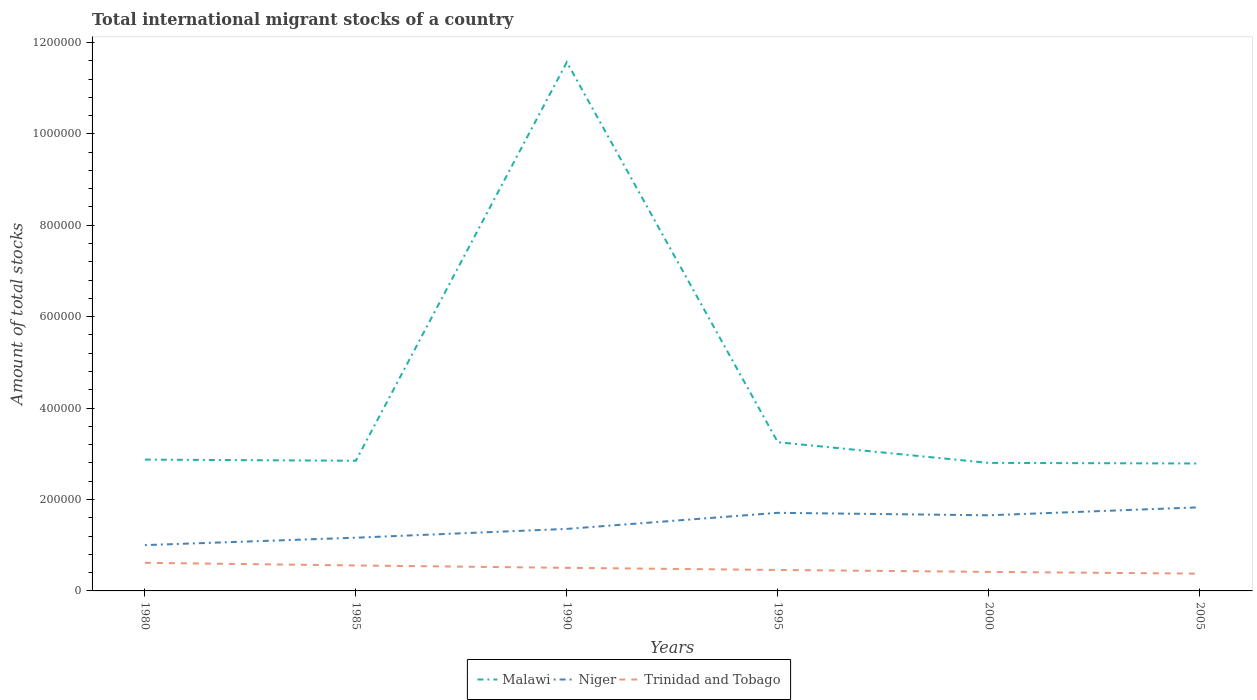Is the number of lines equal to the number of legend labels?
Offer a terse response. Yes. Across all years, what is the maximum amount of total stocks in in Trinidad and Tobago?
Provide a succinct answer. 3.78e+04. In which year was the amount of total stocks in in Niger maximum?
Your response must be concise. 1980. What is the total amount of total stocks in in Niger in the graph?
Offer a terse response. -3.52e+04. What is the difference between the highest and the second highest amount of total stocks in in Niger?
Offer a very short reply. 8.27e+04. How many lines are there?
Ensure brevity in your answer.  3. Does the graph contain any zero values?
Your answer should be very brief. No. Where does the legend appear in the graph?
Your answer should be very brief. Bottom center. How many legend labels are there?
Offer a very short reply. 3. How are the legend labels stacked?
Ensure brevity in your answer.  Horizontal. What is the title of the graph?
Ensure brevity in your answer.  Total international migrant stocks of a country. What is the label or title of the X-axis?
Your response must be concise. Years. What is the label or title of the Y-axis?
Offer a very short reply. Amount of total stocks. What is the Amount of total stocks in Malawi in 1980?
Ensure brevity in your answer.  2.87e+05. What is the Amount of total stocks in Niger in 1980?
Make the answer very short. 1.00e+05. What is the Amount of total stocks in Trinidad and Tobago in 1980?
Make the answer very short. 6.15e+04. What is the Amount of total stocks of Malawi in 1985?
Your response must be concise. 2.85e+05. What is the Amount of total stocks in Niger in 1985?
Offer a terse response. 1.16e+05. What is the Amount of total stocks in Trinidad and Tobago in 1985?
Provide a succinct answer. 5.57e+04. What is the Amount of total stocks of Malawi in 1990?
Offer a terse response. 1.16e+06. What is the Amount of total stocks of Niger in 1990?
Provide a short and direct response. 1.36e+05. What is the Amount of total stocks of Trinidad and Tobago in 1990?
Give a very brief answer. 5.05e+04. What is the Amount of total stocks of Malawi in 1995?
Make the answer very short. 3.25e+05. What is the Amount of total stocks of Niger in 1995?
Ensure brevity in your answer.  1.71e+05. What is the Amount of total stocks in Trinidad and Tobago in 1995?
Your answer should be compact. 4.59e+04. What is the Amount of total stocks of Malawi in 2000?
Your answer should be very brief. 2.80e+05. What is the Amount of total stocks in Niger in 2000?
Offer a terse response. 1.65e+05. What is the Amount of total stocks of Trinidad and Tobago in 2000?
Offer a very short reply. 4.16e+04. What is the Amount of total stocks in Malawi in 2005?
Your answer should be compact. 2.79e+05. What is the Amount of total stocks of Niger in 2005?
Your response must be concise. 1.83e+05. What is the Amount of total stocks of Trinidad and Tobago in 2005?
Give a very brief answer. 3.78e+04. Across all years, what is the maximum Amount of total stocks in Malawi?
Keep it short and to the point. 1.16e+06. Across all years, what is the maximum Amount of total stocks of Niger?
Provide a succinct answer. 1.83e+05. Across all years, what is the maximum Amount of total stocks of Trinidad and Tobago?
Provide a short and direct response. 6.15e+04. Across all years, what is the minimum Amount of total stocks in Malawi?
Your answer should be compact. 2.79e+05. Across all years, what is the minimum Amount of total stocks of Niger?
Your answer should be compact. 1.00e+05. Across all years, what is the minimum Amount of total stocks of Trinidad and Tobago?
Keep it short and to the point. 3.78e+04. What is the total Amount of total stocks of Malawi in the graph?
Offer a very short reply. 2.61e+06. What is the total Amount of total stocks of Niger in the graph?
Provide a short and direct response. 8.72e+05. What is the total Amount of total stocks in Trinidad and Tobago in the graph?
Your answer should be very brief. 2.93e+05. What is the difference between the Amount of total stocks in Malawi in 1980 and that in 1985?
Make the answer very short. 2540. What is the difference between the Amount of total stocks in Niger in 1980 and that in 1985?
Give a very brief answer. -1.62e+04. What is the difference between the Amount of total stocks in Trinidad and Tobago in 1980 and that in 1985?
Give a very brief answer. 5778. What is the difference between the Amount of total stocks in Malawi in 1980 and that in 1990?
Offer a very short reply. -8.70e+05. What is the difference between the Amount of total stocks in Niger in 1980 and that in 1990?
Offer a very short reply. -3.55e+04. What is the difference between the Amount of total stocks of Trinidad and Tobago in 1980 and that in 1990?
Your answer should be compact. 1.10e+04. What is the difference between the Amount of total stocks in Malawi in 1980 and that in 1995?
Keep it short and to the point. -3.81e+04. What is the difference between the Amount of total stocks of Niger in 1980 and that in 1995?
Your answer should be very brief. -7.06e+04. What is the difference between the Amount of total stocks of Trinidad and Tobago in 1980 and that in 1995?
Your answer should be compact. 1.56e+04. What is the difference between the Amount of total stocks in Malawi in 1980 and that in 2000?
Offer a terse response. 7226. What is the difference between the Amount of total stocks of Niger in 1980 and that in 2000?
Your answer should be compact. -6.52e+04. What is the difference between the Amount of total stocks in Trinidad and Tobago in 1980 and that in 2000?
Your answer should be compact. 1.99e+04. What is the difference between the Amount of total stocks in Malawi in 1980 and that in 2005?
Keep it short and to the point. 8516. What is the difference between the Amount of total stocks in Niger in 1980 and that in 2005?
Provide a short and direct response. -8.27e+04. What is the difference between the Amount of total stocks in Trinidad and Tobago in 1980 and that in 2005?
Keep it short and to the point. 2.37e+04. What is the difference between the Amount of total stocks of Malawi in 1985 and that in 1990?
Offer a terse response. -8.72e+05. What is the difference between the Amount of total stocks in Niger in 1985 and that in 1990?
Make the answer very short. -1.92e+04. What is the difference between the Amount of total stocks of Trinidad and Tobago in 1985 and that in 1990?
Ensure brevity in your answer.  5232. What is the difference between the Amount of total stocks of Malawi in 1985 and that in 1995?
Give a very brief answer. -4.06e+04. What is the difference between the Amount of total stocks in Niger in 1985 and that in 1995?
Make the answer very short. -5.44e+04. What is the difference between the Amount of total stocks in Trinidad and Tobago in 1985 and that in 1995?
Your answer should be very brief. 9872. What is the difference between the Amount of total stocks of Malawi in 1985 and that in 2000?
Offer a very short reply. 4686. What is the difference between the Amount of total stocks in Niger in 1985 and that in 2000?
Offer a very short reply. -4.90e+04. What is the difference between the Amount of total stocks of Trinidad and Tobago in 1985 and that in 2000?
Your answer should be very brief. 1.41e+04. What is the difference between the Amount of total stocks in Malawi in 1985 and that in 2005?
Offer a terse response. 5976. What is the difference between the Amount of total stocks of Niger in 1985 and that in 2005?
Make the answer very short. -6.65e+04. What is the difference between the Amount of total stocks in Trinidad and Tobago in 1985 and that in 2005?
Your answer should be very brief. 1.79e+04. What is the difference between the Amount of total stocks in Malawi in 1990 and that in 1995?
Ensure brevity in your answer.  8.31e+05. What is the difference between the Amount of total stocks of Niger in 1990 and that in 1995?
Ensure brevity in your answer.  -3.52e+04. What is the difference between the Amount of total stocks of Trinidad and Tobago in 1990 and that in 1995?
Offer a very short reply. 4640. What is the difference between the Amount of total stocks of Malawi in 1990 and that in 2000?
Offer a very short reply. 8.77e+05. What is the difference between the Amount of total stocks in Niger in 1990 and that in 2000?
Your answer should be very brief. -2.98e+04. What is the difference between the Amount of total stocks of Trinidad and Tobago in 1990 and that in 2000?
Offer a terse response. 8854. What is the difference between the Amount of total stocks in Malawi in 1990 and that in 2005?
Ensure brevity in your answer.  8.78e+05. What is the difference between the Amount of total stocks in Niger in 1990 and that in 2005?
Offer a terse response. -4.73e+04. What is the difference between the Amount of total stocks in Trinidad and Tobago in 1990 and that in 2005?
Your answer should be very brief. 1.27e+04. What is the difference between the Amount of total stocks in Malawi in 1995 and that in 2000?
Offer a very short reply. 4.53e+04. What is the difference between the Amount of total stocks in Niger in 1995 and that in 2000?
Your response must be concise. 5416. What is the difference between the Amount of total stocks of Trinidad and Tobago in 1995 and that in 2000?
Your response must be concise. 4214. What is the difference between the Amount of total stocks of Malawi in 1995 and that in 2005?
Your answer should be compact. 4.66e+04. What is the difference between the Amount of total stocks of Niger in 1995 and that in 2005?
Give a very brief answer. -1.21e+04. What is the difference between the Amount of total stocks of Trinidad and Tobago in 1995 and that in 2005?
Ensure brevity in your answer.  8041. What is the difference between the Amount of total stocks in Malawi in 2000 and that in 2005?
Provide a short and direct response. 1290. What is the difference between the Amount of total stocks of Niger in 2000 and that in 2005?
Provide a short and direct response. -1.75e+04. What is the difference between the Amount of total stocks in Trinidad and Tobago in 2000 and that in 2005?
Your answer should be very brief. 3827. What is the difference between the Amount of total stocks in Malawi in 1980 and the Amount of total stocks in Niger in 1985?
Ensure brevity in your answer.  1.71e+05. What is the difference between the Amount of total stocks of Malawi in 1980 and the Amount of total stocks of Trinidad and Tobago in 1985?
Offer a very short reply. 2.32e+05. What is the difference between the Amount of total stocks of Niger in 1980 and the Amount of total stocks of Trinidad and Tobago in 1985?
Your response must be concise. 4.45e+04. What is the difference between the Amount of total stocks in Malawi in 1980 and the Amount of total stocks in Niger in 1990?
Your answer should be compact. 1.52e+05. What is the difference between the Amount of total stocks of Malawi in 1980 and the Amount of total stocks of Trinidad and Tobago in 1990?
Provide a succinct answer. 2.37e+05. What is the difference between the Amount of total stocks in Niger in 1980 and the Amount of total stocks in Trinidad and Tobago in 1990?
Ensure brevity in your answer.  4.97e+04. What is the difference between the Amount of total stocks in Malawi in 1980 and the Amount of total stocks in Niger in 1995?
Keep it short and to the point. 1.16e+05. What is the difference between the Amount of total stocks in Malawi in 1980 and the Amount of total stocks in Trinidad and Tobago in 1995?
Make the answer very short. 2.41e+05. What is the difference between the Amount of total stocks in Niger in 1980 and the Amount of total stocks in Trinidad and Tobago in 1995?
Your response must be concise. 5.44e+04. What is the difference between the Amount of total stocks in Malawi in 1980 and the Amount of total stocks in Niger in 2000?
Offer a very short reply. 1.22e+05. What is the difference between the Amount of total stocks in Malawi in 1980 and the Amount of total stocks in Trinidad and Tobago in 2000?
Your answer should be very brief. 2.46e+05. What is the difference between the Amount of total stocks of Niger in 1980 and the Amount of total stocks of Trinidad and Tobago in 2000?
Offer a terse response. 5.86e+04. What is the difference between the Amount of total stocks in Malawi in 1980 and the Amount of total stocks in Niger in 2005?
Your answer should be compact. 1.04e+05. What is the difference between the Amount of total stocks in Malawi in 1980 and the Amount of total stocks in Trinidad and Tobago in 2005?
Ensure brevity in your answer.  2.49e+05. What is the difference between the Amount of total stocks of Niger in 1980 and the Amount of total stocks of Trinidad and Tobago in 2005?
Your response must be concise. 6.24e+04. What is the difference between the Amount of total stocks of Malawi in 1985 and the Amount of total stocks of Niger in 1990?
Your response must be concise. 1.49e+05. What is the difference between the Amount of total stocks in Malawi in 1985 and the Amount of total stocks in Trinidad and Tobago in 1990?
Your answer should be compact. 2.34e+05. What is the difference between the Amount of total stocks of Niger in 1985 and the Amount of total stocks of Trinidad and Tobago in 1990?
Make the answer very short. 6.60e+04. What is the difference between the Amount of total stocks of Malawi in 1985 and the Amount of total stocks of Niger in 1995?
Make the answer very short. 1.14e+05. What is the difference between the Amount of total stocks in Malawi in 1985 and the Amount of total stocks in Trinidad and Tobago in 1995?
Keep it short and to the point. 2.39e+05. What is the difference between the Amount of total stocks of Niger in 1985 and the Amount of total stocks of Trinidad and Tobago in 1995?
Your answer should be compact. 7.06e+04. What is the difference between the Amount of total stocks of Malawi in 1985 and the Amount of total stocks of Niger in 2000?
Offer a terse response. 1.19e+05. What is the difference between the Amount of total stocks of Malawi in 1985 and the Amount of total stocks of Trinidad and Tobago in 2000?
Ensure brevity in your answer.  2.43e+05. What is the difference between the Amount of total stocks of Niger in 1985 and the Amount of total stocks of Trinidad and Tobago in 2000?
Ensure brevity in your answer.  7.48e+04. What is the difference between the Amount of total stocks in Malawi in 1985 and the Amount of total stocks in Niger in 2005?
Provide a short and direct response. 1.02e+05. What is the difference between the Amount of total stocks in Malawi in 1985 and the Amount of total stocks in Trinidad and Tobago in 2005?
Provide a short and direct response. 2.47e+05. What is the difference between the Amount of total stocks in Niger in 1985 and the Amount of total stocks in Trinidad and Tobago in 2005?
Provide a succinct answer. 7.86e+04. What is the difference between the Amount of total stocks of Malawi in 1990 and the Amount of total stocks of Niger in 1995?
Your answer should be compact. 9.86e+05. What is the difference between the Amount of total stocks in Malawi in 1990 and the Amount of total stocks in Trinidad and Tobago in 1995?
Offer a very short reply. 1.11e+06. What is the difference between the Amount of total stocks of Niger in 1990 and the Amount of total stocks of Trinidad and Tobago in 1995?
Provide a short and direct response. 8.98e+04. What is the difference between the Amount of total stocks in Malawi in 1990 and the Amount of total stocks in Niger in 2000?
Give a very brief answer. 9.91e+05. What is the difference between the Amount of total stocks of Malawi in 1990 and the Amount of total stocks of Trinidad and Tobago in 2000?
Your answer should be very brief. 1.12e+06. What is the difference between the Amount of total stocks in Niger in 1990 and the Amount of total stocks in Trinidad and Tobago in 2000?
Offer a very short reply. 9.40e+04. What is the difference between the Amount of total stocks of Malawi in 1990 and the Amount of total stocks of Niger in 2005?
Keep it short and to the point. 9.74e+05. What is the difference between the Amount of total stocks in Malawi in 1990 and the Amount of total stocks in Trinidad and Tobago in 2005?
Provide a short and direct response. 1.12e+06. What is the difference between the Amount of total stocks in Niger in 1990 and the Amount of total stocks in Trinidad and Tobago in 2005?
Keep it short and to the point. 9.79e+04. What is the difference between the Amount of total stocks in Malawi in 1995 and the Amount of total stocks in Niger in 2000?
Ensure brevity in your answer.  1.60e+05. What is the difference between the Amount of total stocks of Malawi in 1995 and the Amount of total stocks of Trinidad and Tobago in 2000?
Offer a terse response. 2.84e+05. What is the difference between the Amount of total stocks in Niger in 1995 and the Amount of total stocks in Trinidad and Tobago in 2000?
Your answer should be very brief. 1.29e+05. What is the difference between the Amount of total stocks in Malawi in 1995 and the Amount of total stocks in Niger in 2005?
Offer a very short reply. 1.42e+05. What is the difference between the Amount of total stocks in Malawi in 1995 and the Amount of total stocks in Trinidad and Tobago in 2005?
Your response must be concise. 2.88e+05. What is the difference between the Amount of total stocks in Niger in 1995 and the Amount of total stocks in Trinidad and Tobago in 2005?
Your answer should be compact. 1.33e+05. What is the difference between the Amount of total stocks in Malawi in 2000 and the Amount of total stocks in Niger in 2005?
Ensure brevity in your answer.  9.71e+04. What is the difference between the Amount of total stocks of Malawi in 2000 and the Amount of total stocks of Trinidad and Tobago in 2005?
Provide a short and direct response. 2.42e+05. What is the difference between the Amount of total stocks in Niger in 2000 and the Amount of total stocks in Trinidad and Tobago in 2005?
Ensure brevity in your answer.  1.28e+05. What is the average Amount of total stocks in Malawi per year?
Provide a short and direct response. 4.36e+05. What is the average Amount of total stocks of Niger per year?
Keep it short and to the point. 1.45e+05. What is the average Amount of total stocks of Trinidad and Tobago per year?
Ensure brevity in your answer.  4.88e+04. In the year 1980, what is the difference between the Amount of total stocks of Malawi and Amount of total stocks of Niger?
Offer a very short reply. 1.87e+05. In the year 1980, what is the difference between the Amount of total stocks of Malawi and Amount of total stocks of Trinidad and Tobago?
Provide a short and direct response. 2.26e+05. In the year 1980, what is the difference between the Amount of total stocks in Niger and Amount of total stocks in Trinidad and Tobago?
Your response must be concise. 3.87e+04. In the year 1985, what is the difference between the Amount of total stocks in Malawi and Amount of total stocks in Niger?
Your answer should be compact. 1.68e+05. In the year 1985, what is the difference between the Amount of total stocks of Malawi and Amount of total stocks of Trinidad and Tobago?
Provide a short and direct response. 2.29e+05. In the year 1985, what is the difference between the Amount of total stocks in Niger and Amount of total stocks in Trinidad and Tobago?
Provide a succinct answer. 6.07e+04. In the year 1990, what is the difference between the Amount of total stocks of Malawi and Amount of total stocks of Niger?
Your response must be concise. 1.02e+06. In the year 1990, what is the difference between the Amount of total stocks of Malawi and Amount of total stocks of Trinidad and Tobago?
Ensure brevity in your answer.  1.11e+06. In the year 1990, what is the difference between the Amount of total stocks of Niger and Amount of total stocks of Trinidad and Tobago?
Provide a short and direct response. 8.52e+04. In the year 1995, what is the difference between the Amount of total stocks of Malawi and Amount of total stocks of Niger?
Your answer should be very brief. 1.55e+05. In the year 1995, what is the difference between the Amount of total stocks of Malawi and Amount of total stocks of Trinidad and Tobago?
Your answer should be very brief. 2.80e+05. In the year 1995, what is the difference between the Amount of total stocks in Niger and Amount of total stocks in Trinidad and Tobago?
Keep it short and to the point. 1.25e+05. In the year 2000, what is the difference between the Amount of total stocks in Malawi and Amount of total stocks in Niger?
Give a very brief answer. 1.15e+05. In the year 2000, what is the difference between the Amount of total stocks in Malawi and Amount of total stocks in Trinidad and Tobago?
Offer a terse response. 2.38e+05. In the year 2000, what is the difference between the Amount of total stocks of Niger and Amount of total stocks of Trinidad and Tobago?
Keep it short and to the point. 1.24e+05. In the year 2005, what is the difference between the Amount of total stocks in Malawi and Amount of total stocks in Niger?
Keep it short and to the point. 9.58e+04. In the year 2005, what is the difference between the Amount of total stocks of Malawi and Amount of total stocks of Trinidad and Tobago?
Make the answer very short. 2.41e+05. In the year 2005, what is the difference between the Amount of total stocks of Niger and Amount of total stocks of Trinidad and Tobago?
Ensure brevity in your answer.  1.45e+05. What is the ratio of the Amount of total stocks in Malawi in 1980 to that in 1985?
Offer a terse response. 1.01. What is the ratio of the Amount of total stocks in Niger in 1980 to that in 1985?
Your answer should be very brief. 0.86. What is the ratio of the Amount of total stocks of Trinidad and Tobago in 1980 to that in 1985?
Provide a short and direct response. 1.1. What is the ratio of the Amount of total stocks of Malawi in 1980 to that in 1990?
Provide a succinct answer. 0.25. What is the ratio of the Amount of total stocks in Niger in 1980 to that in 1990?
Your response must be concise. 0.74. What is the ratio of the Amount of total stocks of Trinidad and Tobago in 1980 to that in 1990?
Provide a short and direct response. 1.22. What is the ratio of the Amount of total stocks in Malawi in 1980 to that in 1995?
Provide a succinct answer. 0.88. What is the ratio of the Amount of total stocks of Niger in 1980 to that in 1995?
Make the answer very short. 0.59. What is the ratio of the Amount of total stocks in Trinidad and Tobago in 1980 to that in 1995?
Your answer should be compact. 1.34. What is the ratio of the Amount of total stocks in Malawi in 1980 to that in 2000?
Provide a short and direct response. 1.03. What is the ratio of the Amount of total stocks in Niger in 1980 to that in 2000?
Keep it short and to the point. 0.61. What is the ratio of the Amount of total stocks in Trinidad and Tobago in 1980 to that in 2000?
Keep it short and to the point. 1.48. What is the ratio of the Amount of total stocks of Malawi in 1980 to that in 2005?
Provide a short and direct response. 1.03. What is the ratio of the Amount of total stocks in Niger in 1980 to that in 2005?
Provide a succinct answer. 0.55. What is the ratio of the Amount of total stocks in Trinidad and Tobago in 1980 to that in 2005?
Keep it short and to the point. 1.63. What is the ratio of the Amount of total stocks in Malawi in 1985 to that in 1990?
Offer a terse response. 0.25. What is the ratio of the Amount of total stocks in Niger in 1985 to that in 1990?
Keep it short and to the point. 0.86. What is the ratio of the Amount of total stocks of Trinidad and Tobago in 1985 to that in 1990?
Provide a short and direct response. 1.1. What is the ratio of the Amount of total stocks of Malawi in 1985 to that in 1995?
Provide a succinct answer. 0.88. What is the ratio of the Amount of total stocks in Niger in 1985 to that in 1995?
Provide a succinct answer. 0.68. What is the ratio of the Amount of total stocks of Trinidad and Tobago in 1985 to that in 1995?
Provide a succinct answer. 1.22. What is the ratio of the Amount of total stocks in Malawi in 1985 to that in 2000?
Provide a short and direct response. 1.02. What is the ratio of the Amount of total stocks in Niger in 1985 to that in 2000?
Make the answer very short. 0.7. What is the ratio of the Amount of total stocks of Trinidad and Tobago in 1985 to that in 2000?
Keep it short and to the point. 1.34. What is the ratio of the Amount of total stocks in Malawi in 1985 to that in 2005?
Give a very brief answer. 1.02. What is the ratio of the Amount of total stocks of Niger in 1985 to that in 2005?
Your answer should be very brief. 0.64. What is the ratio of the Amount of total stocks in Trinidad and Tobago in 1985 to that in 2005?
Provide a short and direct response. 1.47. What is the ratio of the Amount of total stocks of Malawi in 1990 to that in 1995?
Your answer should be very brief. 3.56. What is the ratio of the Amount of total stocks in Niger in 1990 to that in 1995?
Your response must be concise. 0.79. What is the ratio of the Amount of total stocks in Trinidad and Tobago in 1990 to that in 1995?
Your answer should be compact. 1.1. What is the ratio of the Amount of total stocks of Malawi in 1990 to that in 2000?
Offer a terse response. 4.13. What is the ratio of the Amount of total stocks of Niger in 1990 to that in 2000?
Give a very brief answer. 0.82. What is the ratio of the Amount of total stocks of Trinidad and Tobago in 1990 to that in 2000?
Your answer should be very brief. 1.21. What is the ratio of the Amount of total stocks in Malawi in 1990 to that in 2005?
Ensure brevity in your answer.  4.15. What is the ratio of the Amount of total stocks of Niger in 1990 to that in 2005?
Give a very brief answer. 0.74. What is the ratio of the Amount of total stocks of Trinidad and Tobago in 1990 to that in 2005?
Provide a short and direct response. 1.34. What is the ratio of the Amount of total stocks of Malawi in 1995 to that in 2000?
Make the answer very short. 1.16. What is the ratio of the Amount of total stocks of Niger in 1995 to that in 2000?
Offer a terse response. 1.03. What is the ratio of the Amount of total stocks of Trinidad and Tobago in 1995 to that in 2000?
Give a very brief answer. 1.1. What is the ratio of the Amount of total stocks in Malawi in 1995 to that in 2005?
Make the answer very short. 1.17. What is the ratio of the Amount of total stocks in Niger in 1995 to that in 2005?
Provide a succinct answer. 0.93. What is the ratio of the Amount of total stocks of Trinidad and Tobago in 1995 to that in 2005?
Provide a succinct answer. 1.21. What is the ratio of the Amount of total stocks in Niger in 2000 to that in 2005?
Offer a terse response. 0.9. What is the ratio of the Amount of total stocks in Trinidad and Tobago in 2000 to that in 2005?
Offer a very short reply. 1.1. What is the difference between the highest and the second highest Amount of total stocks in Malawi?
Offer a very short reply. 8.31e+05. What is the difference between the highest and the second highest Amount of total stocks in Niger?
Make the answer very short. 1.21e+04. What is the difference between the highest and the second highest Amount of total stocks of Trinidad and Tobago?
Give a very brief answer. 5778. What is the difference between the highest and the lowest Amount of total stocks in Malawi?
Offer a very short reply. 8.78e+05. What is the difference between the highest and the lowest Amount of total stocks in Niger?
Provide a succinct answer. 8.27e+04. What is the difference between the highest and the lowest Amount of total stocks in Trinidad and Tobago?
Provide a succinct answer. 2.37e+04. 